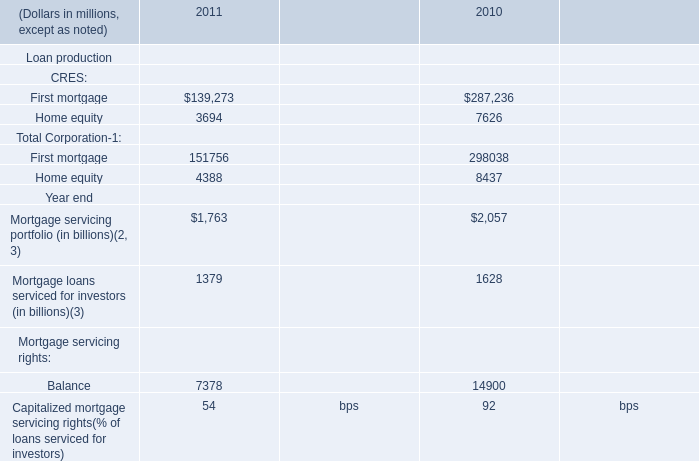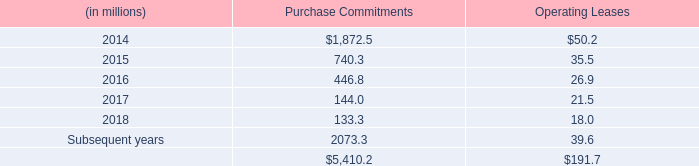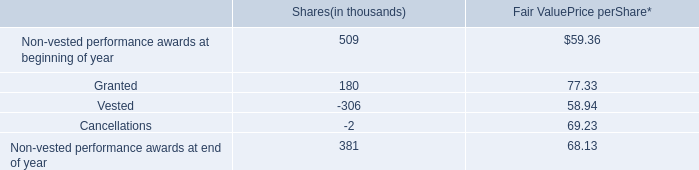What is the growing rate of First mortgage of CRES in table 0 in the years with the least Home equity of CRES in table 0? 
Computations: ((139273 - 287236) / 287236)
Answer: -0.51513. 